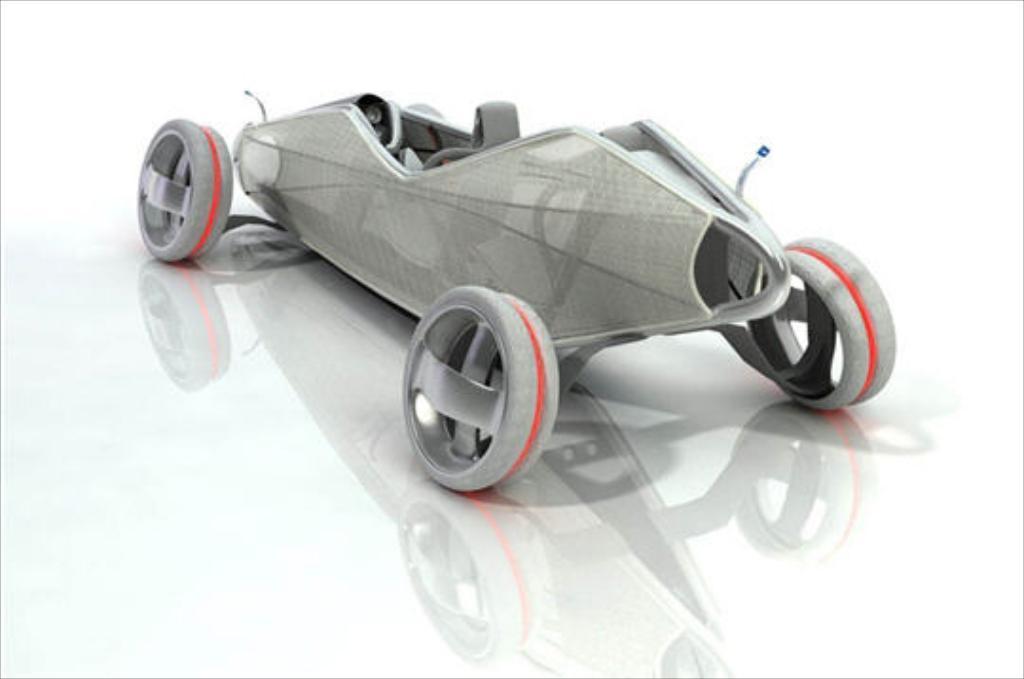Can you describe this image briefly? In this picture there is a concept car in the center of the image. 